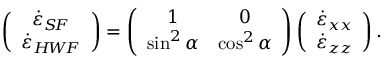<formula> <loc_0><loc_0><loc_500><loc_500>\left ( \begin{array} { c } { \dot { \varepsilon } _ { S \, F } } \\ { \dot { \varepsilon } _ { H \, W \, F } } \end{array} \right ) = \left ( \begin{array} { c c } { 1 } & { 0 } \\ { \sin ^ { 2 } \alpha } & { \cos ^ { 2 } \alpha } \end{array} \right ) \left ( \begin{array} { c } { \dot { \varepsilon } _ { x x } } \\ { \dot { \varepsilon } _ { z z } } \end{array} \right ) .</formula> 